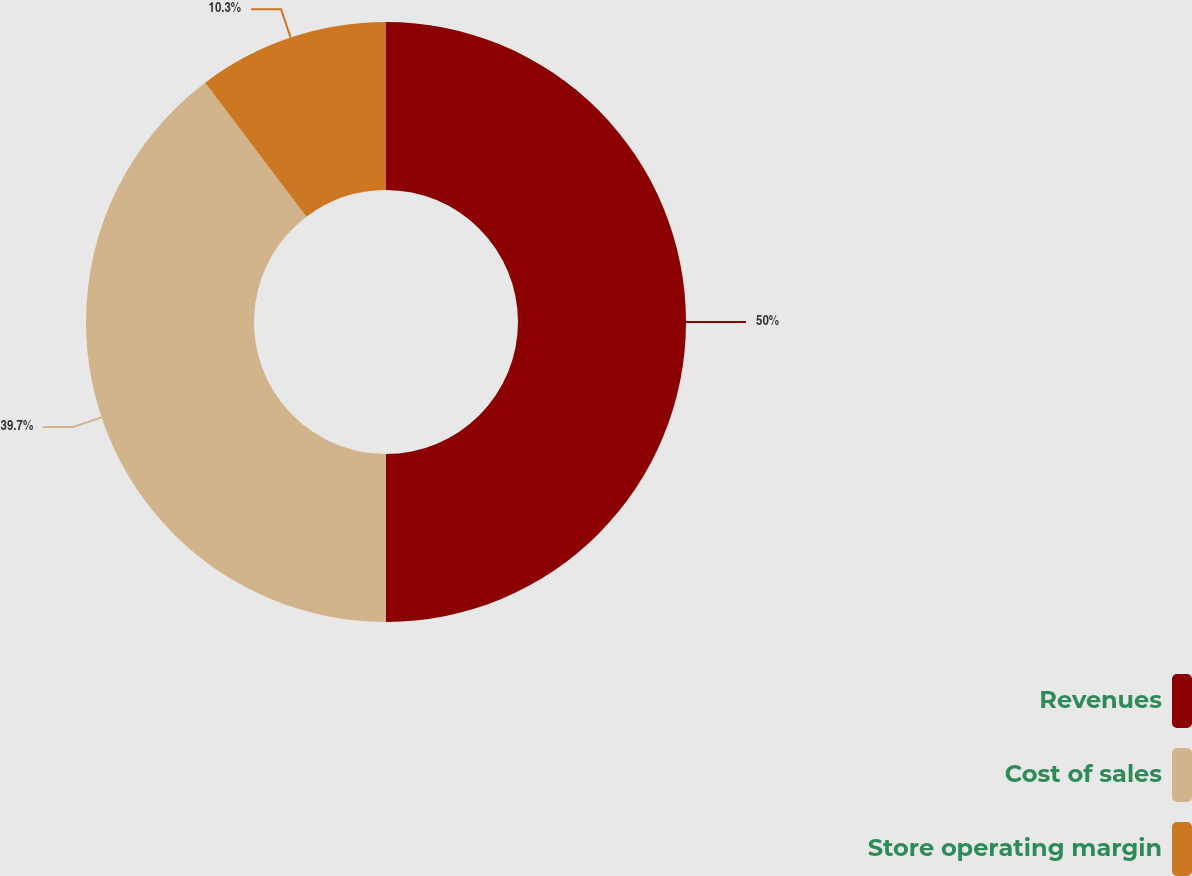Convert chart to OTSL. <chart><loc_0><loc_0><loc_500><loc_500><pie_chart><fcel>Revenues<fcel>Cost of sales<fcel>Store operating margin<nl><fcel>50.0%<fcel>39.7%<fcel>10.3%<nl></chart> 